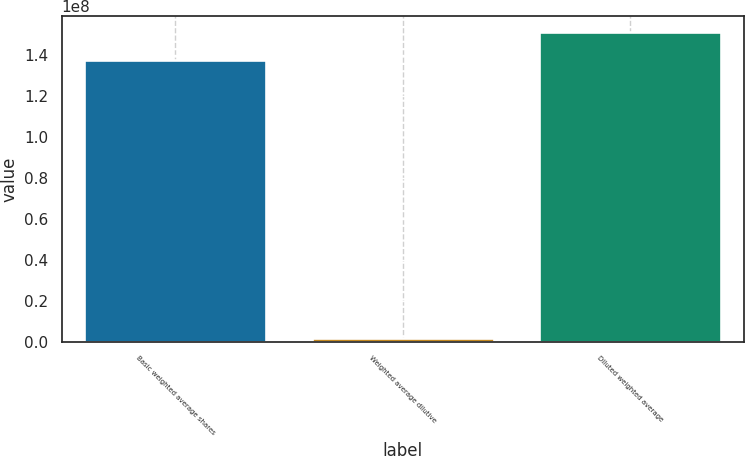Convert chart. <chart><loc_0><loc_0><loc_500><loc_500><bar_chart><fcel>Basic weighted average shares<fcel>Weighted average dilutive<fcel>Diluted weighted average<nl><fcel>1.37647e+08<fcel>1.9169e+06<fcel>1.51412e+08<nl></chart> 